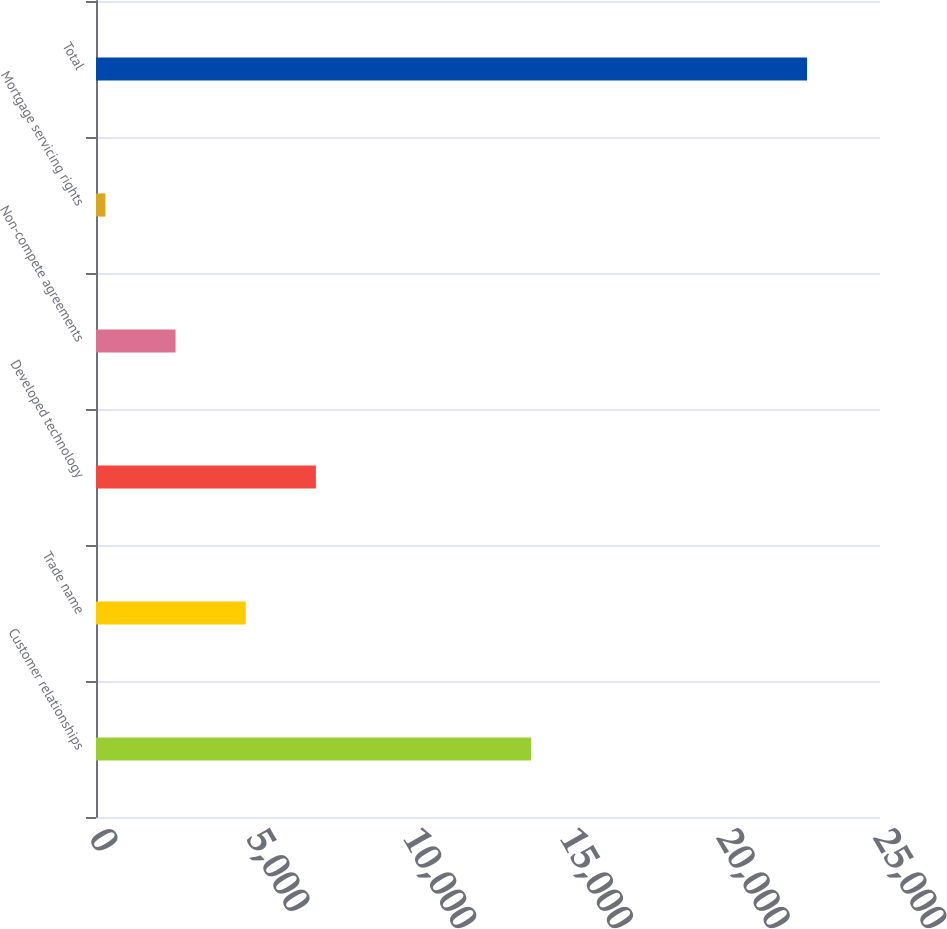<chart> <loc_0><loc_0><loc_500><loc_500><bar_chart><fcel>Customer relationships<fcel>Trade name<fcel>Developed technology<fcel>Non-compete agreements<fcel>Mortgage servicing rights<fcel>Total<nl><fcel>13875<fcel>4775<fcel>7012.5<fcel>2537.5<fcel>300<fcel>22675<nl></chart> 